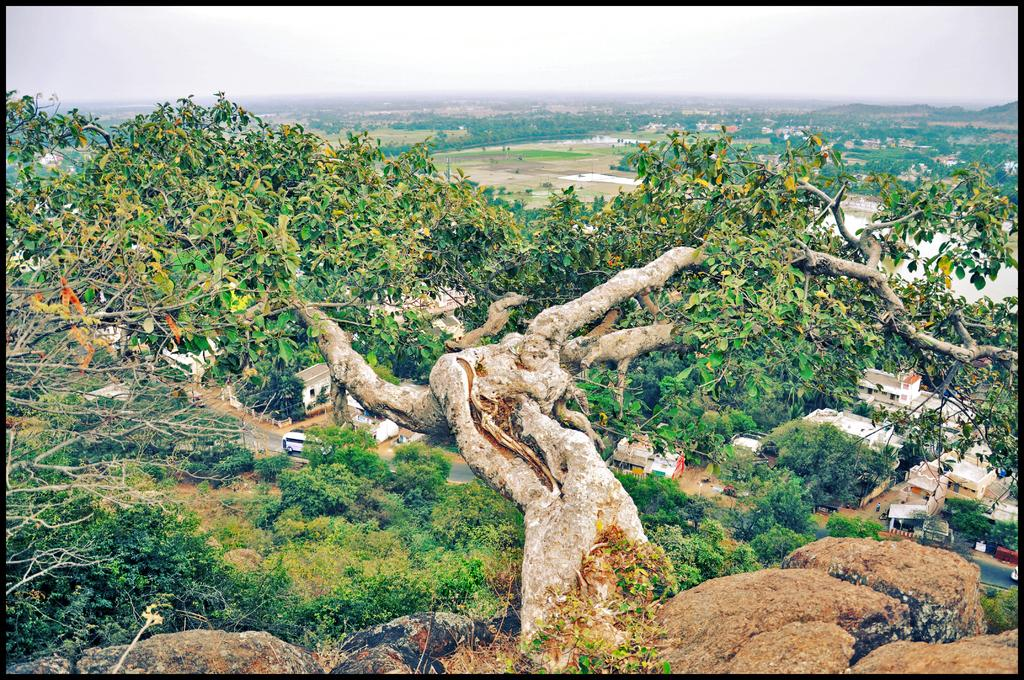What is located in the foreground of the image? There is a tree on a rock in the foreground of the image. What can be seen in the background of the image? In the background of the image, there is a road, trees, buildings, water, the city, mountains, and the sky. Can you describe the natural elements visible in the image? The image features a tree on a rock, water, and mountains. What type of man-made structures are visible in the image? The image shows a road, buildings, and a city. How many islands can be seen in the image? There are no islands visible in the image. What type of cracker is being used to build the city in the background? There is no cracker present in the image, and the city is not being built; it is already constructed. 